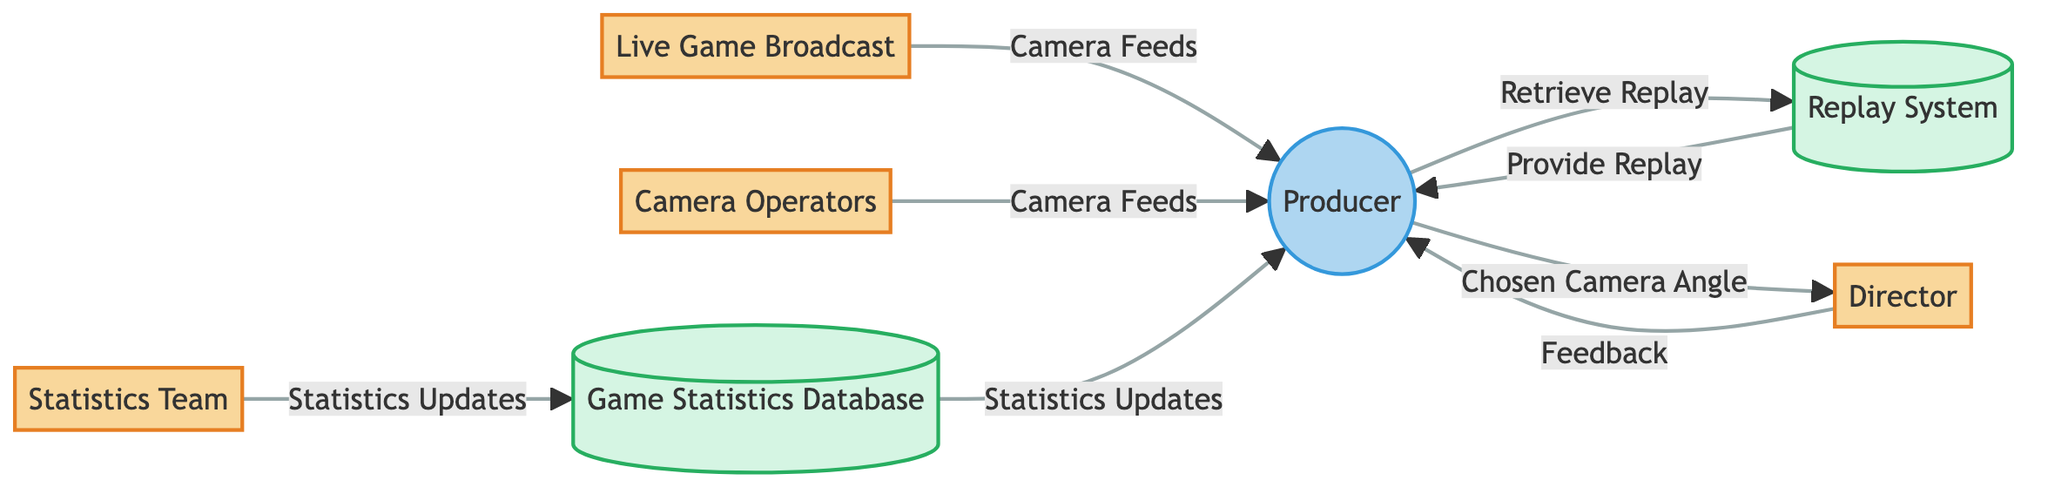What is the main process in this diagram? The main process in this diagram is the "Producer," who coordinates camera angles during the live game broadcast.
Answer: Producer How many external entities are present in the diagram? There are four external entities shown in the diagram: "Live Game Broadcast," "Camera Operators," "Director," and "Statistics Team."
Answer: 4 What data flow represents the chosen camera angle? The data flow representing the chosen camera angle is labeled as "Chosen Camera Angle."
Answer: Chosen Camera Angle Which external entity provides real-time statistics to the producer? The "Statistics Team" is the external entity responsible for providing real-time game statistics to the producer.
Answer: Statistics Team What data store does the producer retrieve footage from? The producer retrieves footage from the "Replay System."
Answer: Replay System What feedback does the director give to the producer? The director gives "Feedback" to the producer regarding camera angle choices.
Answer: Feedback Which data flow comes from the game statistics database? The data flow that comes from the game statistics database is labeled "Statistics Updates."
Answer: Statistics Updates How does the producer interact with the replay system? The producer interacts with the replay system by sending a request labeled "Retrieve Replay."
Answer: Retrieve Replay What is the relationship between the producer and the director? The relationship is depicted by the data flow "Feedback," which goes from the director to the producer about camera angles.
Answer: Feedback What do camera operators provide to the producer? Camera operators provide "Camera Feeds" to the producer for decision making.
Answer: Camera Feeds 